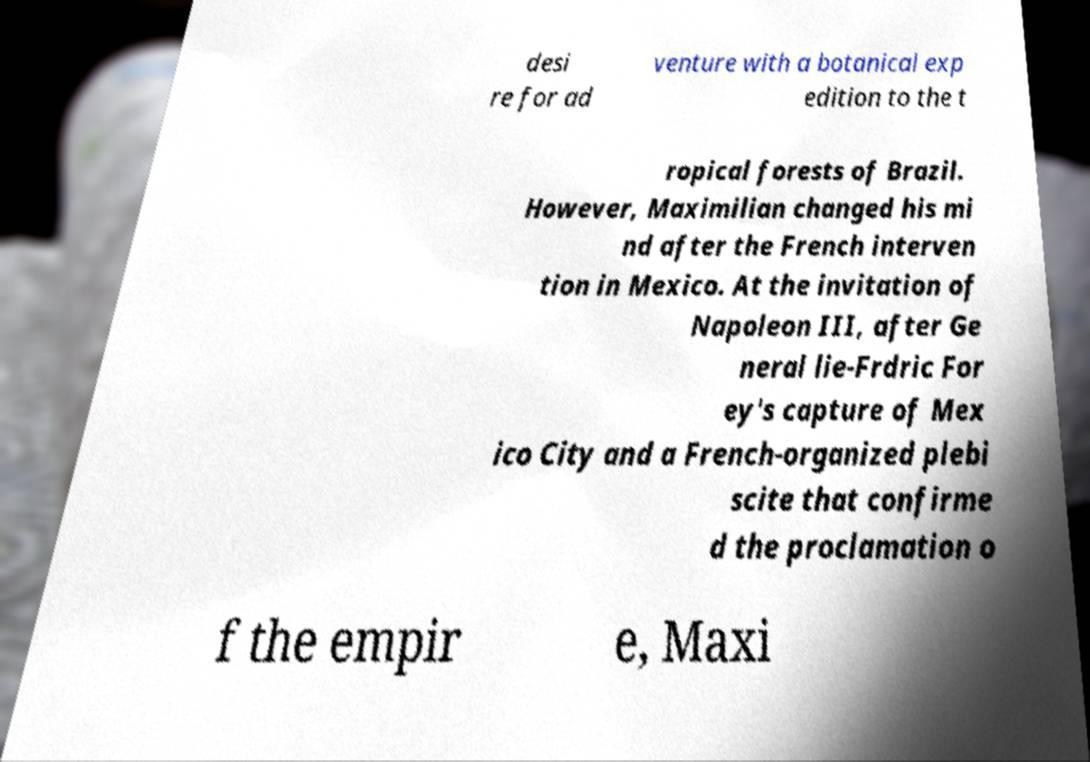What messages or text are displayed in this image? I need them in a readable, typed format. desi re for ad venture with a botanical exp edition to the t ropical forests of Brazil. However, Maximilian changed his mi nd after the French interven tion in Mexico. At the invitation of Napoleon III, after Ge neral lie-Frdric For ey's capture of Mex ico City and a French-organized plebi scite that confirme d the proclamation o f the empir e, Maxi 